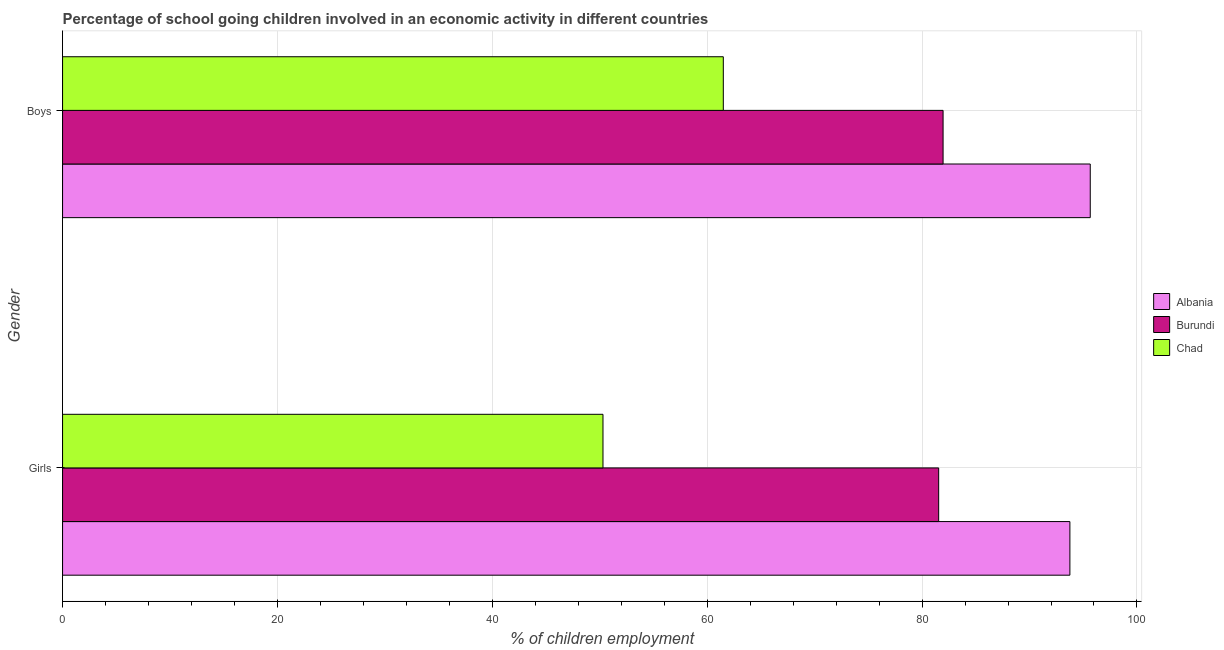How many bars are there on the 2nd tick from the top?
Keep it short and to the point. 3. What is the label of the 1st group of bars from the top?
Your response must be concise. Boys. What is the percentage of school going girls in Chad?
Keep it short and to the point. 50.3. Across all countries, what is the maximum percentage of school going girls?
Offer a terse response. 93.76. Across all countries, what is the minimum percentage of school going girls?
Your answer should be compact. 50.3. In which country was the percentage of school going girls maximum?
Offer a terse response. Albania. In which country was the percentage of school going boys minimum?
Make the answer very short. Chad. What is the total percentage of school going girls in the graph?
Provide a short and direct response. 225.6. What is the difference between the percentage of school going girls in Burundi and that in Chad?
Give a very brief answer. 31.24. What is the difference between the percentage of school going girls in Burundi and the percentage of school going boys in Chad?
Give a very brief answer. 20.04. What is the average percentage of school going girls per country?
Keep it short and to the point. 75.2. What is the difference between the percentage of school going boys and percentage of school going girls in Burundi?
Give a very brief answer. 0.41. In how many countries, is the percentage of school going girls greater than 12 %?
Your response must be concise. 3. What is the ratio of the percentage of school going boys in Albania to that in Chad?
Ensure brevity in your answer.  1.56. What does the 1st bar from the top in Girls represents?
Keep it short and to the point. Chad. What does the 2nd bar from the bottom in Boys represents?
Provide a short and direct response. Burundi. Are all the bars in the graph horizontal?
Provide a succinct answer. Yes. How many countries are there in the graph?
Make the answer very short. 3. Does the graph contain any zero values?
Provide a short and direct response. No. Does the graph contain grids?
Ensure brevity in your answer.  Yes. How are the legend labels stacked?
Offer a terse response. Vertical. What is the title of the graph?
Give a very brief answer. Percentage of school going children involved in an economic activity in different countries. What is the label or title of the X-axis?
Provide a short and direct response. % of children employment. What is the label or title of the Y-axis?
Ensure brevity in your answer.  Gender. What is the % of children employment of Albania in Girls?
Offer a very short reply. 93.76. What is the % of children employment of Burundi in Girls?
Your answer should be compact. 81.54. What is the % of children employment of Chad in Girls?
Keep it short and to the point. 50.3. What is the % of children employment of Albania in Boys?
Keep it short and to the point. 95.65. What is the % of children employment in Burundi in Boys?
Keep it short and to the point. 81.96. What is the % of children employment of Chad in Boys?
Make the answer very short. 61.5. Across all Gender, what is the maximum % of children employment in Albania?
Keep it short and to the point. 95.65. Across all Gender, what is the maximum % of children employment of Burundi?
Make the answer very short. 81.96. Across all Gender, what is the maximum % of children employment in Chad?
Ensure brevity in your answer.  61.5. Across all Gender, what is the minimum % of children employment in Albania?
Provide a succinct answer. 93.76. Across all Gender, what is the minimum % of children employment of Burundi?
Offer a very short reply. 81.54. Across all Gender, what is the minimum % of children employment of Chad?
Your answer should be very brief. 50.3. What is the total % of children employment in Albania in the graph?
Offer a terse response. 189.41. What is the total % of children employment of Burundi in the graph?
Make the answer very short. 163.5. What is the total % of children employment of Chad in the graph?
Provide a short and direct response. 111.8. What is the difference between the % of children employment in Albania in Girls and that in Boys?
Your answer should be compact. -1.89. What is the difference between the % of children employment of Burundi in Girls and that in Boys?
Your response must be concise. -0.41. What is the difference between the % of children employment of Albania in Girls and the % of children employment of Burundi in Boys?
Ensure brevity in your answer.  11.8. What is the difference between the % of children employment of Albania in Girls and the % of children employment of Chad in Boys?
Offer a very short reply. 32.26. What is the difference between the % of children employment of Burundi in Girls and the % of children employment of Chad in Boys?
Offer a terse response. 20.04. What is the average % of children employment of Albania per Gender?
Give a very brief answer. 94.71. What is the average % of children employment of Burundi per Gender?
Give a very brief answer. 81.75. What is the average % of children employment in Chad per Gender?
Your answer should be compact. 55.9. What is the difference between the % of children employment in Albania and % of children employment in Burundi in Girls?
Your answer should be very brief. 12.21. What is the difference between the % of children employment in Albania and % of children employment in Chad in Girls?
Keep it short and to the point. 43.46. What is the difference between the % of children employment of Burundi and % of children employment of Chad in Girls?
Make the answer very short. 31.24. What is the difference between the % of children employment in Albania and % of children employment in Burundi in Boys?
Make the answer very short. 13.7. What is the difference between the % of children employment of Albania and % of children employment of Chad in Boys?
Your response must be concise. 34.15. What is the difference between the % of children employment in Burundi and % of children employment in Chad in Boys?
Offer a terse response. 20.45. What is the ratio of the % of children employment in Albania in Girls to that in Boys?
Ensure brevity in your answer.  0.98. What is the ratio of the % of children employment of Chad in Girls to that in Boys?
Ensure brevity in your answer.  0.82. What is the difference between the highest and the second highest % of children employment of Albania?
Your response must be concise. 1.89. What is the difference between the highest and the second highest % of children employment in Burundi?
Keep it short and to the point. 0.41. What is the difference between the highest and the lowest % of children employment of Albania?
Offer a terse response. 1.89. What is the difference between the highest and the lowest % of children employment of Burundi?
Your answer should be very brief. 0.41. What is the difference between the highest and the lowest % of children employment in Chad?
Keep it short and to the point. 11.2. 